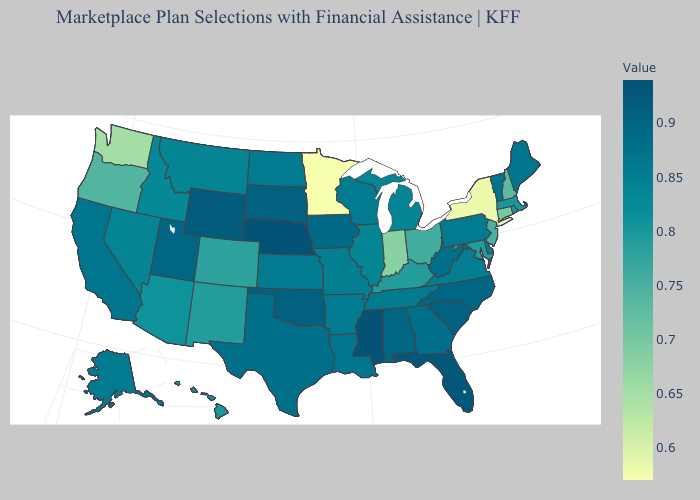Does the map have missing data?
Short answer required. No. Does Illinois have the highest value in the MidWest?
Give a very brief answer. No. Does Montana have a lower value than Nebraska?
Be succinct. Yes. Which states have the lowest value in the Northeast?
Give a very brief answer. New York. Does the map have missing data?
Concise answer only. No. 